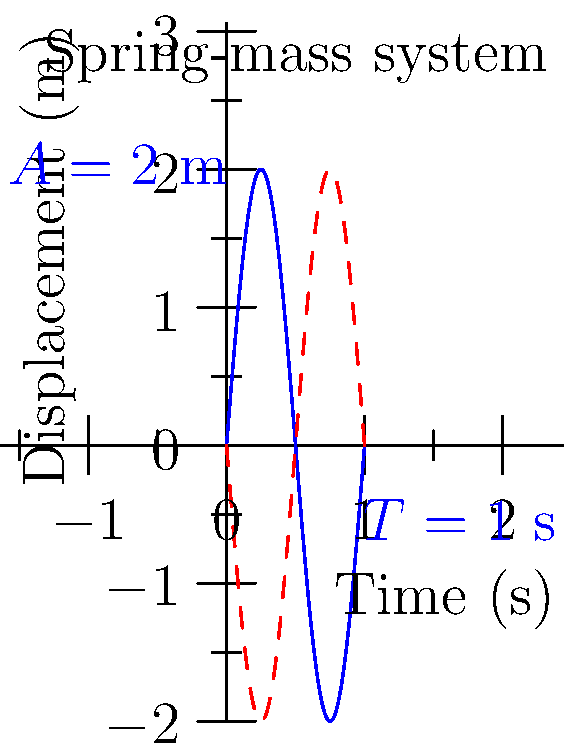As a banking regulations expert, you're assessing a risk management system that uses oscillation patterns to model market volatility. The system employs a spring-mass analogy, where the displacement represents market deviation from equilibrium. Given the graph of a simple harmonic motion with amplitude $A = 2$ m and period $T = 1$ s, calculate the maximum velocity of this oscillation. How might this relate to rapid market fluctuations in your risk assessment? To solve this problem, we'll follow these steps:

1) In simple harmonic motion, the angular frequency $\omega$ is related to the period $T$ by:
   $$\omega = \frac{2\pi}{T}$$

2) Given $T = 1$ s, we can calculate $\omega$:
   $$\omega = \frac{2\pi}{1} = 2\pi \text{ rad/s}$$

3) The displacement in simple harmonic motion is given by:
   $$x(t) = A \sin(\omega t)$$
   where $A$ is the amplitude.

4) The velocity is the derivative of displacement with respect to time:
   $$v(t) = \frac{dx}{dt} = A\omega \cos(\omega t)$$

5) The maximum velocity occurs when $\cos(\omega t) = \pm 1$, so:
   $$v_{max} = A\omega = 2 \cdot 2\pi = 4\pi \text{ m/s}$$

In the context of risk assessment, this maximum velocity could represent the rate of change in market value during periods of high volatility. A higher maximum velocity might indicate a higher risk of rapid, significant market movements, which could impact the bank's risk exposure and regulatory compliance.
Answer: $4\pi$ m/s 